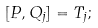Convert formula to latex. <formula><loc_0><loc_0><loc_500><loc_500>[ P , Q _ { j } ] = T _ { j } ;</formula> 